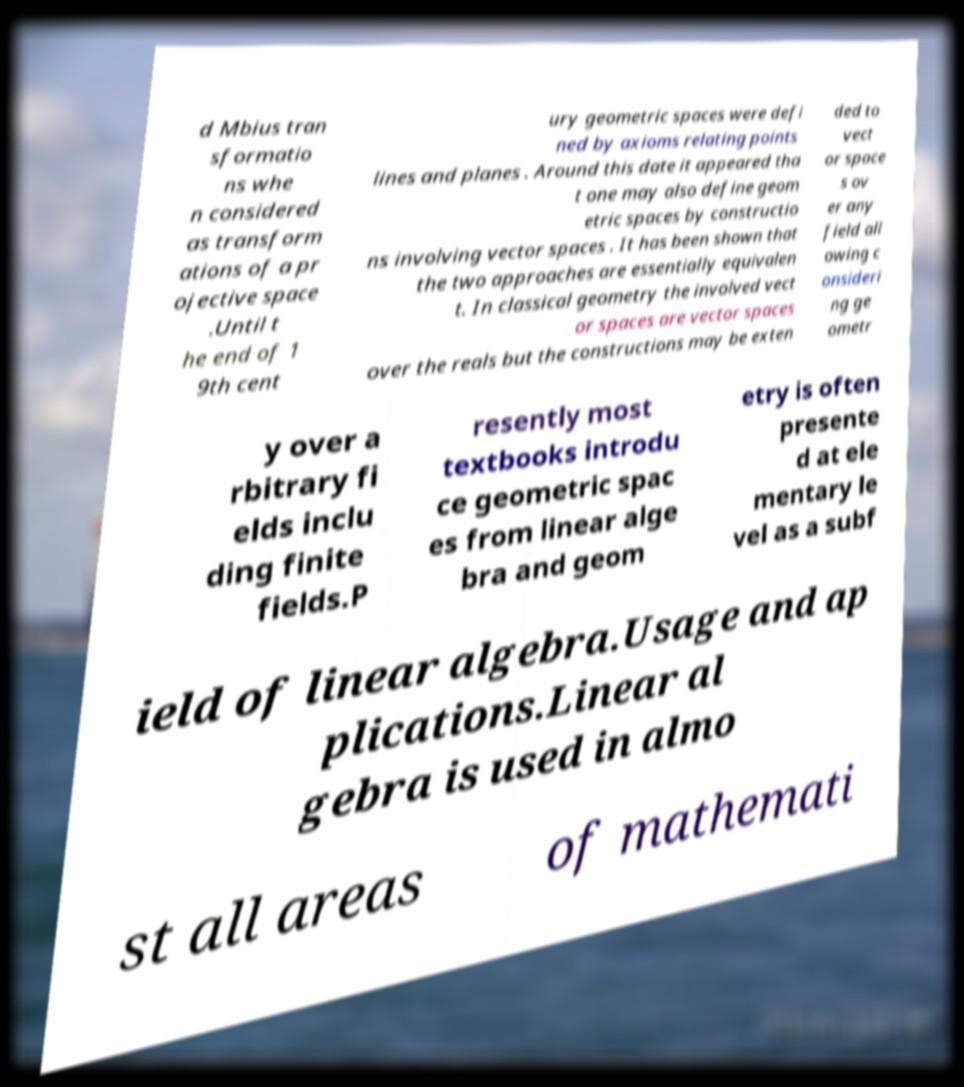There's text embedded in this image that I need extracted. Can you transcribe it verbatim? d Mbius tran sformatio ns whe n considered as transform ations of a pr ojective space .Until t he end of 1 9th cent ury geometric spaces were defi ned by axioms relating points lines and planes . Around this date it appeared tha t one may also define geom etric spaces by constructio ns involving vector spaces . It has been shown that the two approaches are essentially equivalen t. In classical geometry the involved vect or spaces are vector spaces over the reals but the constructions may be exten ded to vect or space s ov er any field all owing c onsideri ng ge ometr y over a rbitrary fi elds inclu ding finite fields.P resently most textbooks introdu ce geometric spac es from linear alge bra and geom etry is often presente d at ele mentary le vel as a subf ield of linear algebra.Usage and ap plications.Linear al gebra is used in almo st all areas of mathemati 